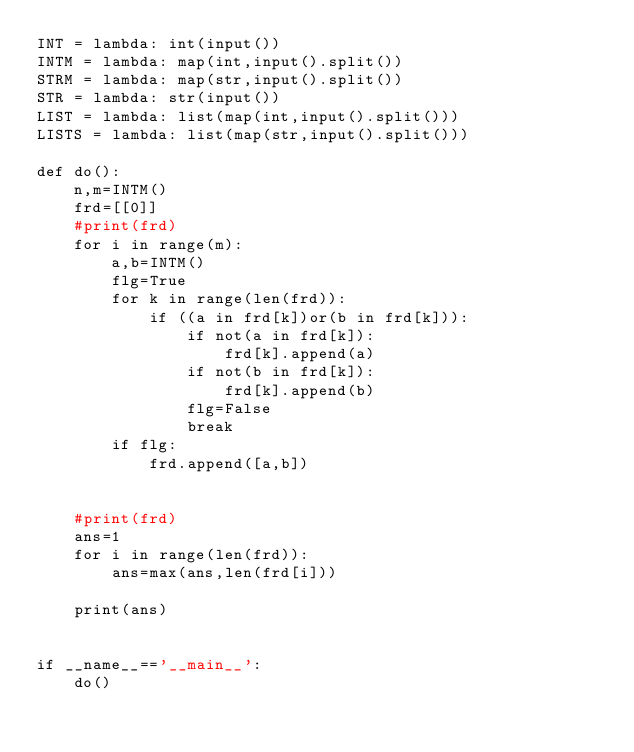<code> <loc_0><loc_0><loc_500><loc_500><_Python_>INT = lambda: int(input())
INTM = lambda: map(int,input().split())
STRM = lambda: map(str,input().split())
STR = lambda: str(input())
LIST = lambda: list(map(int,input().split()))
LISTS = lambda: list(map(str,input().split()))

def do():
    n,m=INTM()
    frd=[[0]]
    #print(frd)
    for i in range(m):
        a,b=INTM()
        flg=True
        for k in range(len(frd)):
            if ((a in frd[k])or(b in frd[k])):
                if not(a in frd[k]):
                    frd[k].append(a)
                if not(b in frd[k]):
                    frd[k].append(b)
                flg=False
                break
        if flg:
            frd.append([a,b])
            
                
    #print(frd)
    ans=1
    for i in range(len(frd)):
        ans=max(ans,len(frd[i]))
    
    print(ans)

                
if __name__=='__main__':
    do()</code> 